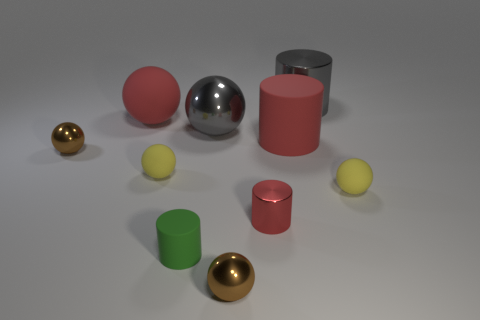There is a tiny brown thing in front of the small metal thing to the left of the big gray metallic ball; how many red metallic cylinders are in front of it?
Provide a short and direct response. 0. Are there any gray objects behind the tiny rubber cylinder?
Your answer should be compact. Yes. What number of big gray things are made of the same material as the gray ball?
Offer a terse response. 1. How many objects are either tiny brown metallic spheres or tiny red cylinders?
Provide a succinct answer. 3. Are there any large green rubber balls?
Offer a very short reply. No. What is the material of the big gray thing that is right of the tiny brown thing in front of the yellow matte object to the right of the gray metallic cylinder?
Your answer should be compact. Metal. Are there fewer gray metallic cylinders behind the small green thing than yellow objects?
Offer a terse response. Yes. What material is the green cylinder that is the same size as the red metal object?
Offer a very short reply. Rubber. There is a metallic ball that is in front of the red matte cylinder and behind the tiny red shiny cylinder; what size is it?
Keep it short and to the point. Small. There is a green object that is the same shape as the small red shiny thing; what size is it?
Make the answer very short. Small. 